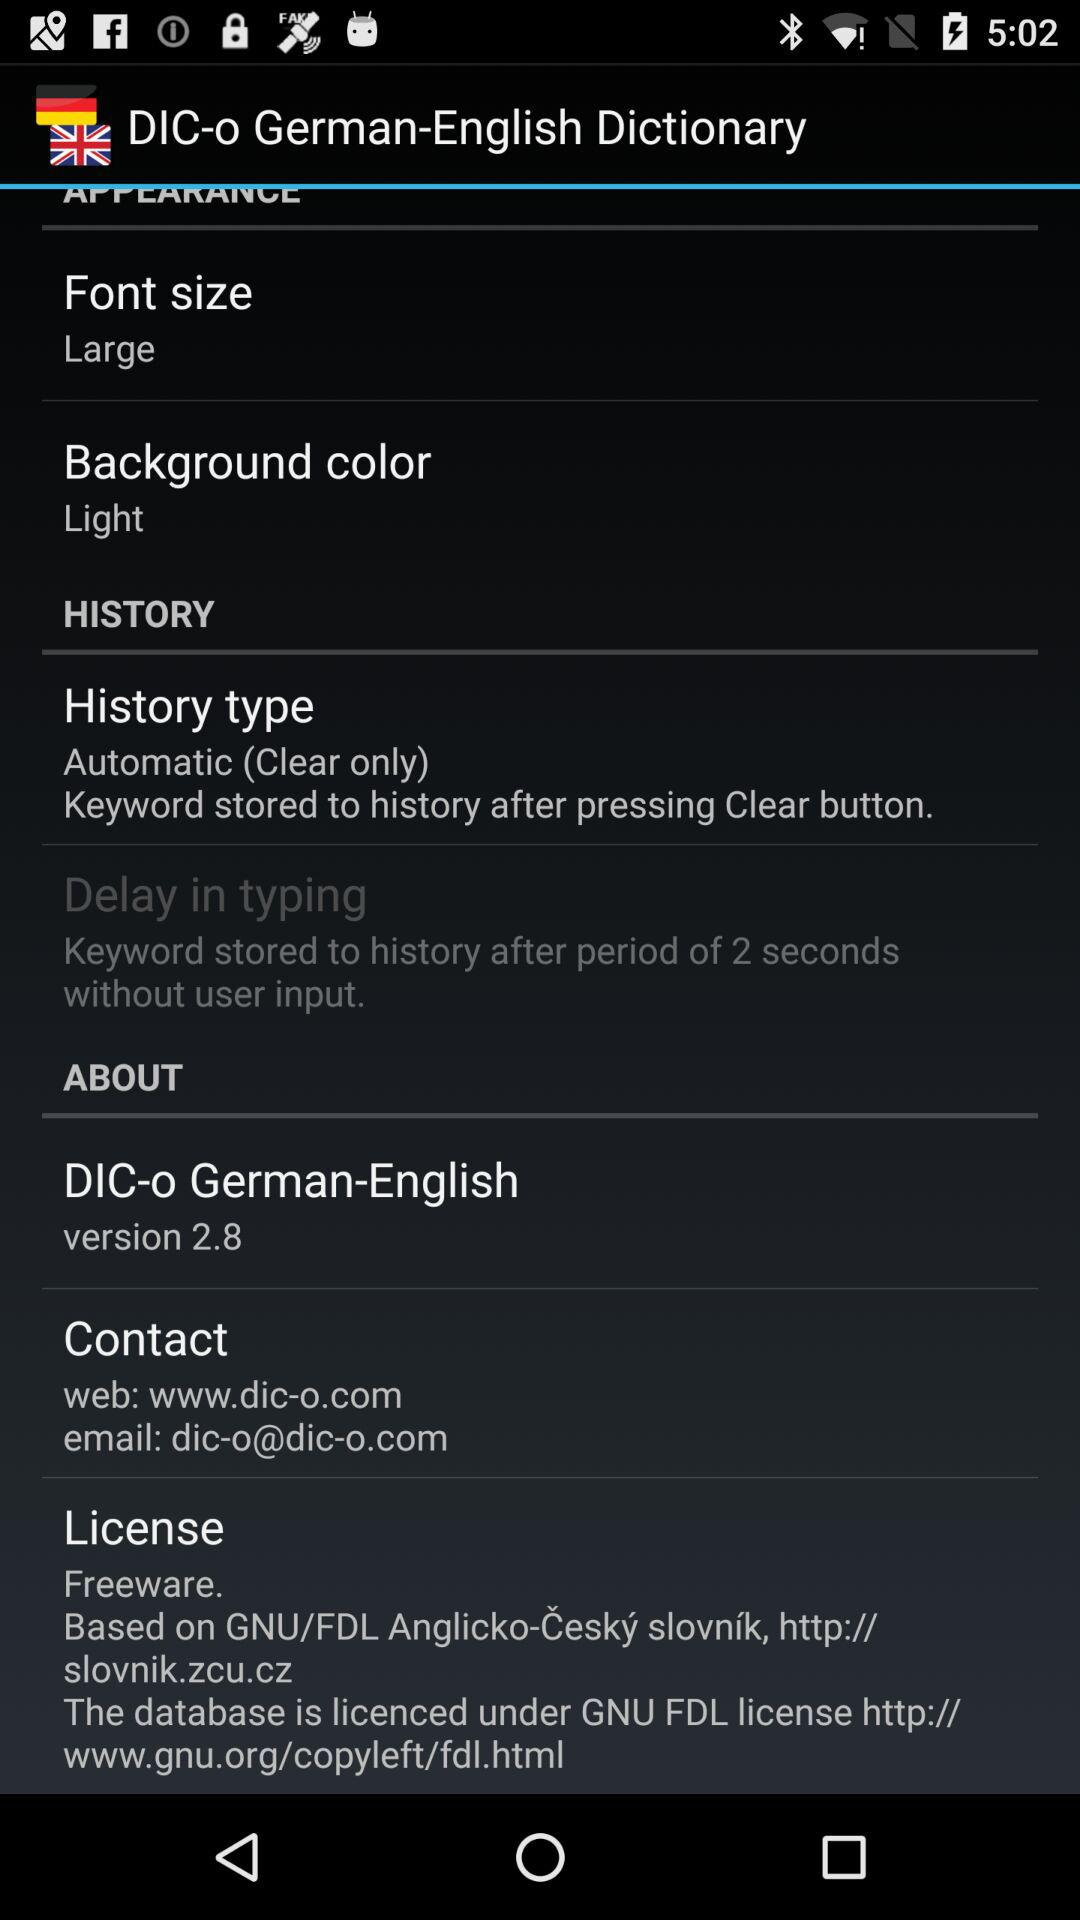After how much time are the keywords stored in history without user input? The keywords are stored in history without user input after a period of 2 seconds. 